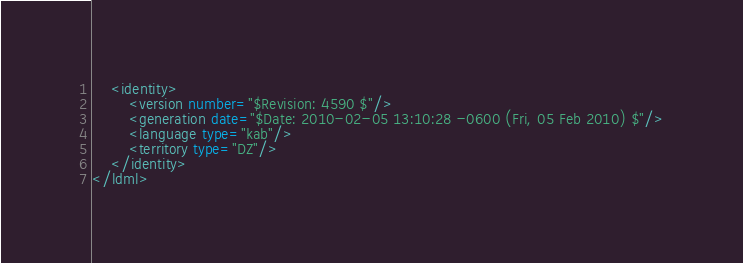<code> <loc_0><loc_0><loc_500><loc_500><_XML_>	<identity>
		<version number="$Revision: 4590 $"/>
		<generation date="$Date: 2010-02-05 13:10:28 -0600 (Fri, 05 Feb 2010) $"/>
		<language type="kab"/>
		<territory type="DZ"/>
	</identity>
</ldml>
</code> 